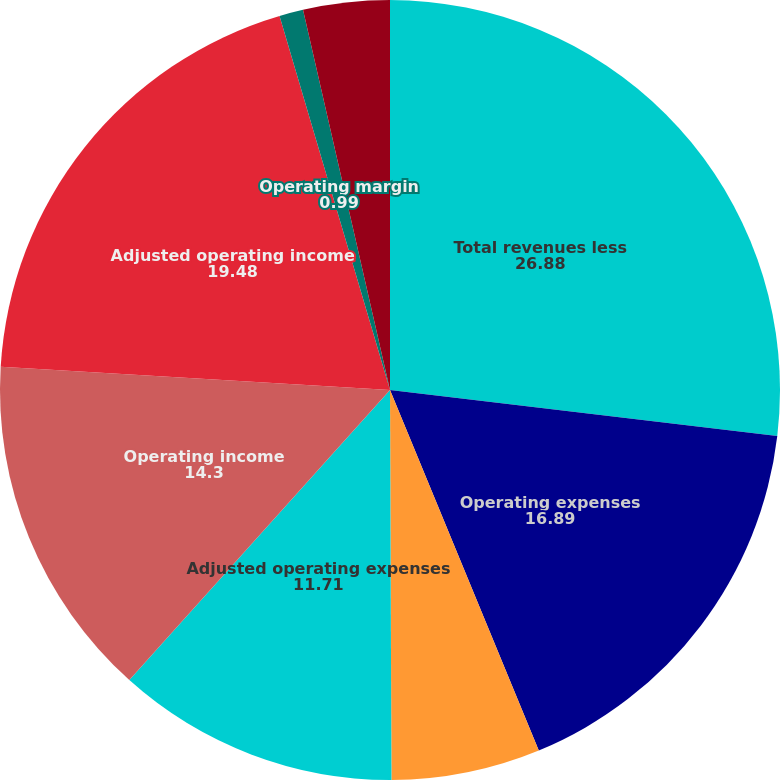<chart> <loc_0><loc_0><loc_500><loc_500><pie_chart><fcel>Total revenues less<fcel>Operating expenses<fcel>Less Amortization of<fcel>Adjusted operating expenses<fcel>Operating income<fcel>Adjusted operating income<fcel>Operating margin<fcel>Adjusted operating margin<nl><fcel>26.88%<fcel>16.89%<fcel>6.17%<fcel>11.71%<fcel>14.3%<fcel>19.48%<fcel>0.99%<fcel>3.58%<nl></chart> 